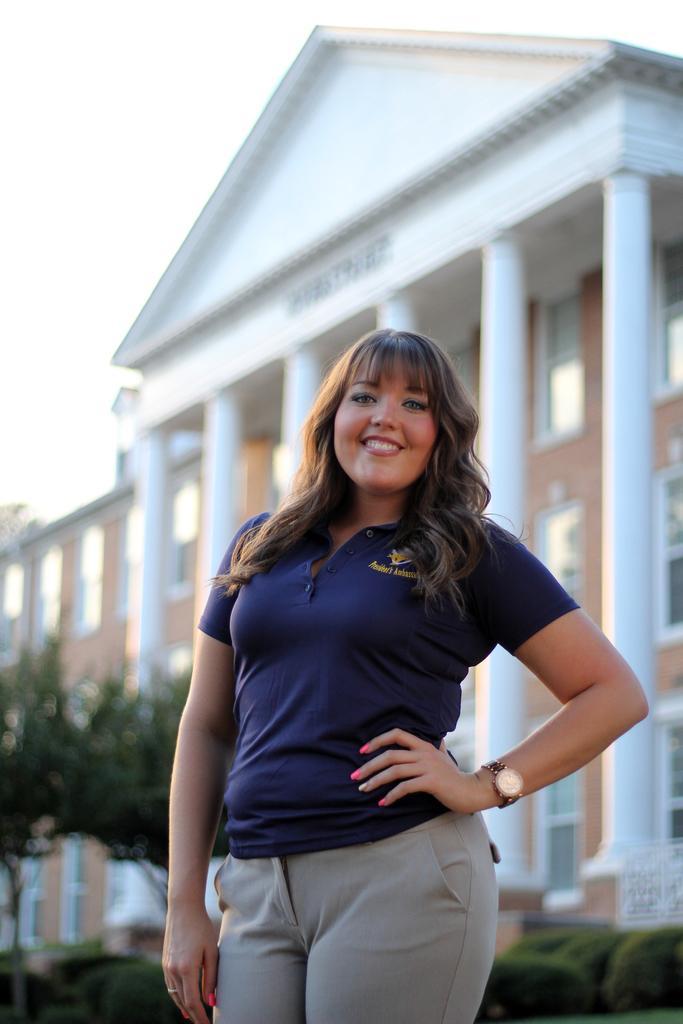Please provide a concise description of this image. In this picture I can observe a woman wearing blue color T shirt. The woman is smiling. In the background I can observe some trees and plants. There is a building in the background. 